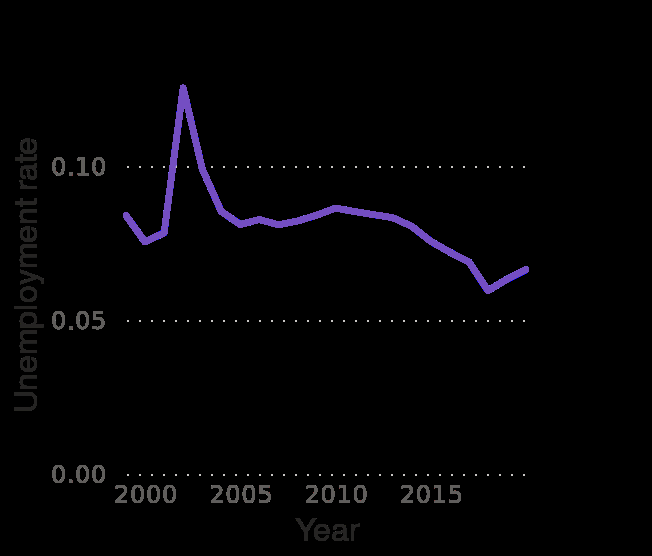<image>
What is the range of the x-axis in the line chart? The range of the x-axis in the line chart is from 2000 to 2015. 